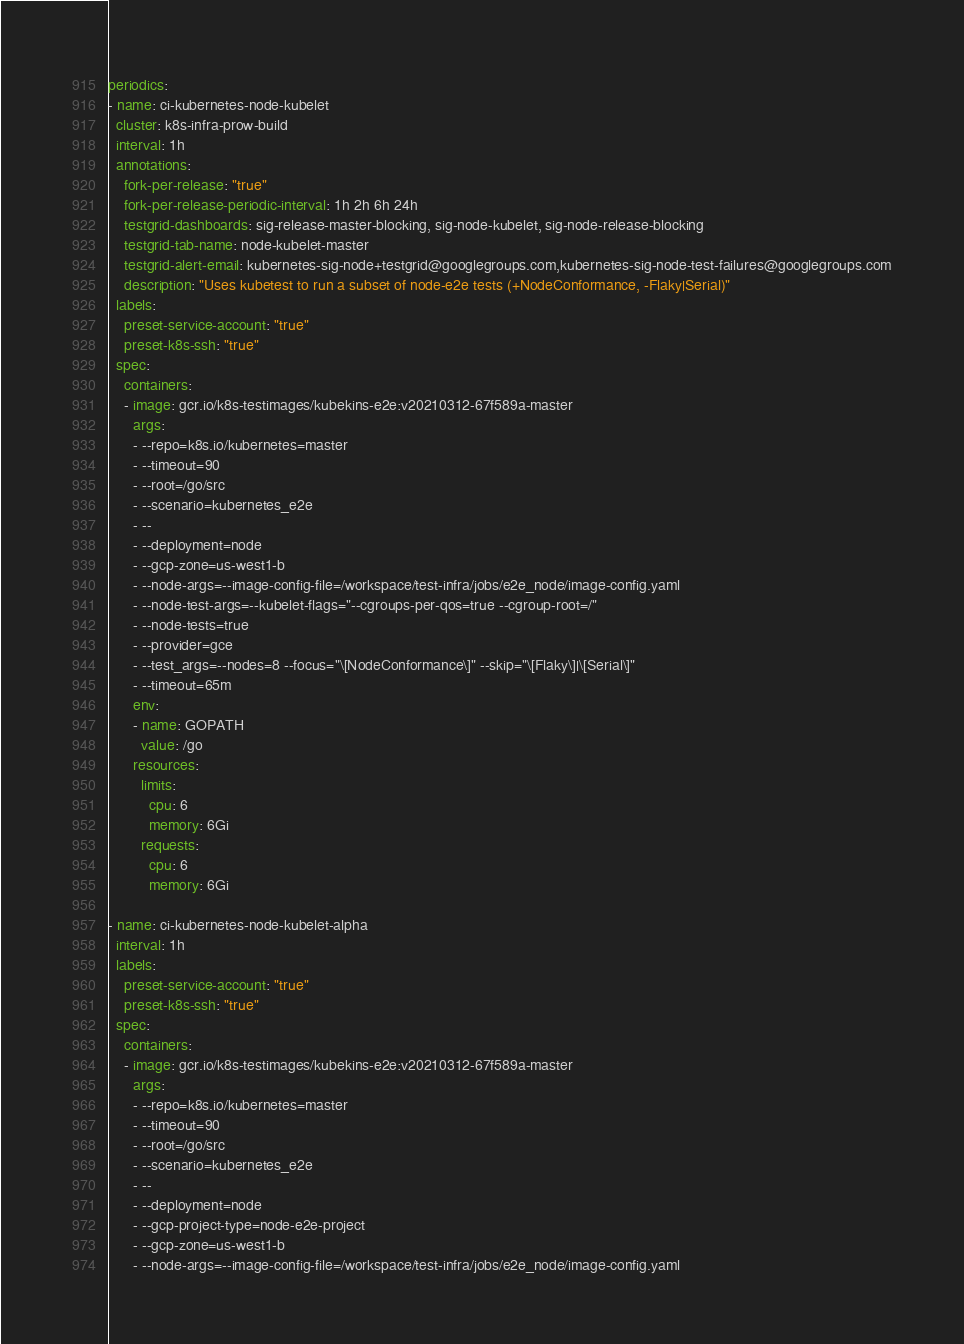<code> <loc_0><loc_0><loc_500><loc_500><_YAML_>periodics:
- name: ci-kubernetes-node-kubelet
  cluster: k8s-infra-prow-build
  interval: 1h
  annotations:
    fork-per-release: "true"
    fork-per-release-periodic-interval: 1h 2h 6h 24h
    testgrid-dashboards: sig-release-master-blocking, sig-node-kubelet, sig-node-release-blocking
    testgrid-tab-name: node-kubelet-master
    testgrid-alert-email: kubernetes-sig-node+testgrid@googlegroups.com,kubernetes-sig-node-test-failures@googlegroups.com
    description: "Uses kubetest to run a subset of node-e2e tests (+NodeConformance, -Flaky|Serial)"
  labels:
    preset-service-account: "true"
    preset-k8s-ssh: "true"
  spec:
    containers:
    - image: gcr.io/k8s-testimages/kubekins-e2e:v20210312-67f589a-master
      args:
      - --repo=k8s.io/kubernetes=master
      - --timeout=90
      - --root=/go/src
      - --scenario=kubernetes_e2e
      - --
      - --deployment=node
      - --gcp-zone=us-west1-b
      - --node-args=--image-config-file=/workspace/test-infra/jobs/e2e_node/image-config.yaml
      - --node-test-args=--kubelet-flags="--cgroups-per-qos=true --cgroup-root=/"
      - --node-tests=true
      - --provider=gce
      - --test_args=--nodes=8 --focus="\[NodeConformance\]" --skip="\[Flaky\]|\[Serial\]"
      - --timeout=65m
      env:
      - name: GOPATH
        value: /go
      resources:
        limits:
          cpu: 6
          memory: 6Gi
        requests:
          cpu: 6
          memory: 6Gi

- name: ci-kubernetes-node-kubelet-alpha
  interval: 1h
  labels:
    preset-service-account: "true"
    preset-k8s-ssh: "true"
  spec:
    containers:
    - image: gcr.io/k8s-testimages/kubekins-e2e:v20210312-67f589a-master
      args:
      - --repo=k8s.io/kubernetes=master
      - --timeout=90
      - --root=/go/src
      - --scenario=kubernetes_e2e
      - --
      - --deployment=node
      - --gcp-project-type=node-e2e-project
      - --gcp-zone=us-west1-b
      - --node-args=--image-config-file=/workspace/test-infra/jobs/e2e_node/image-config.yaml</code> 